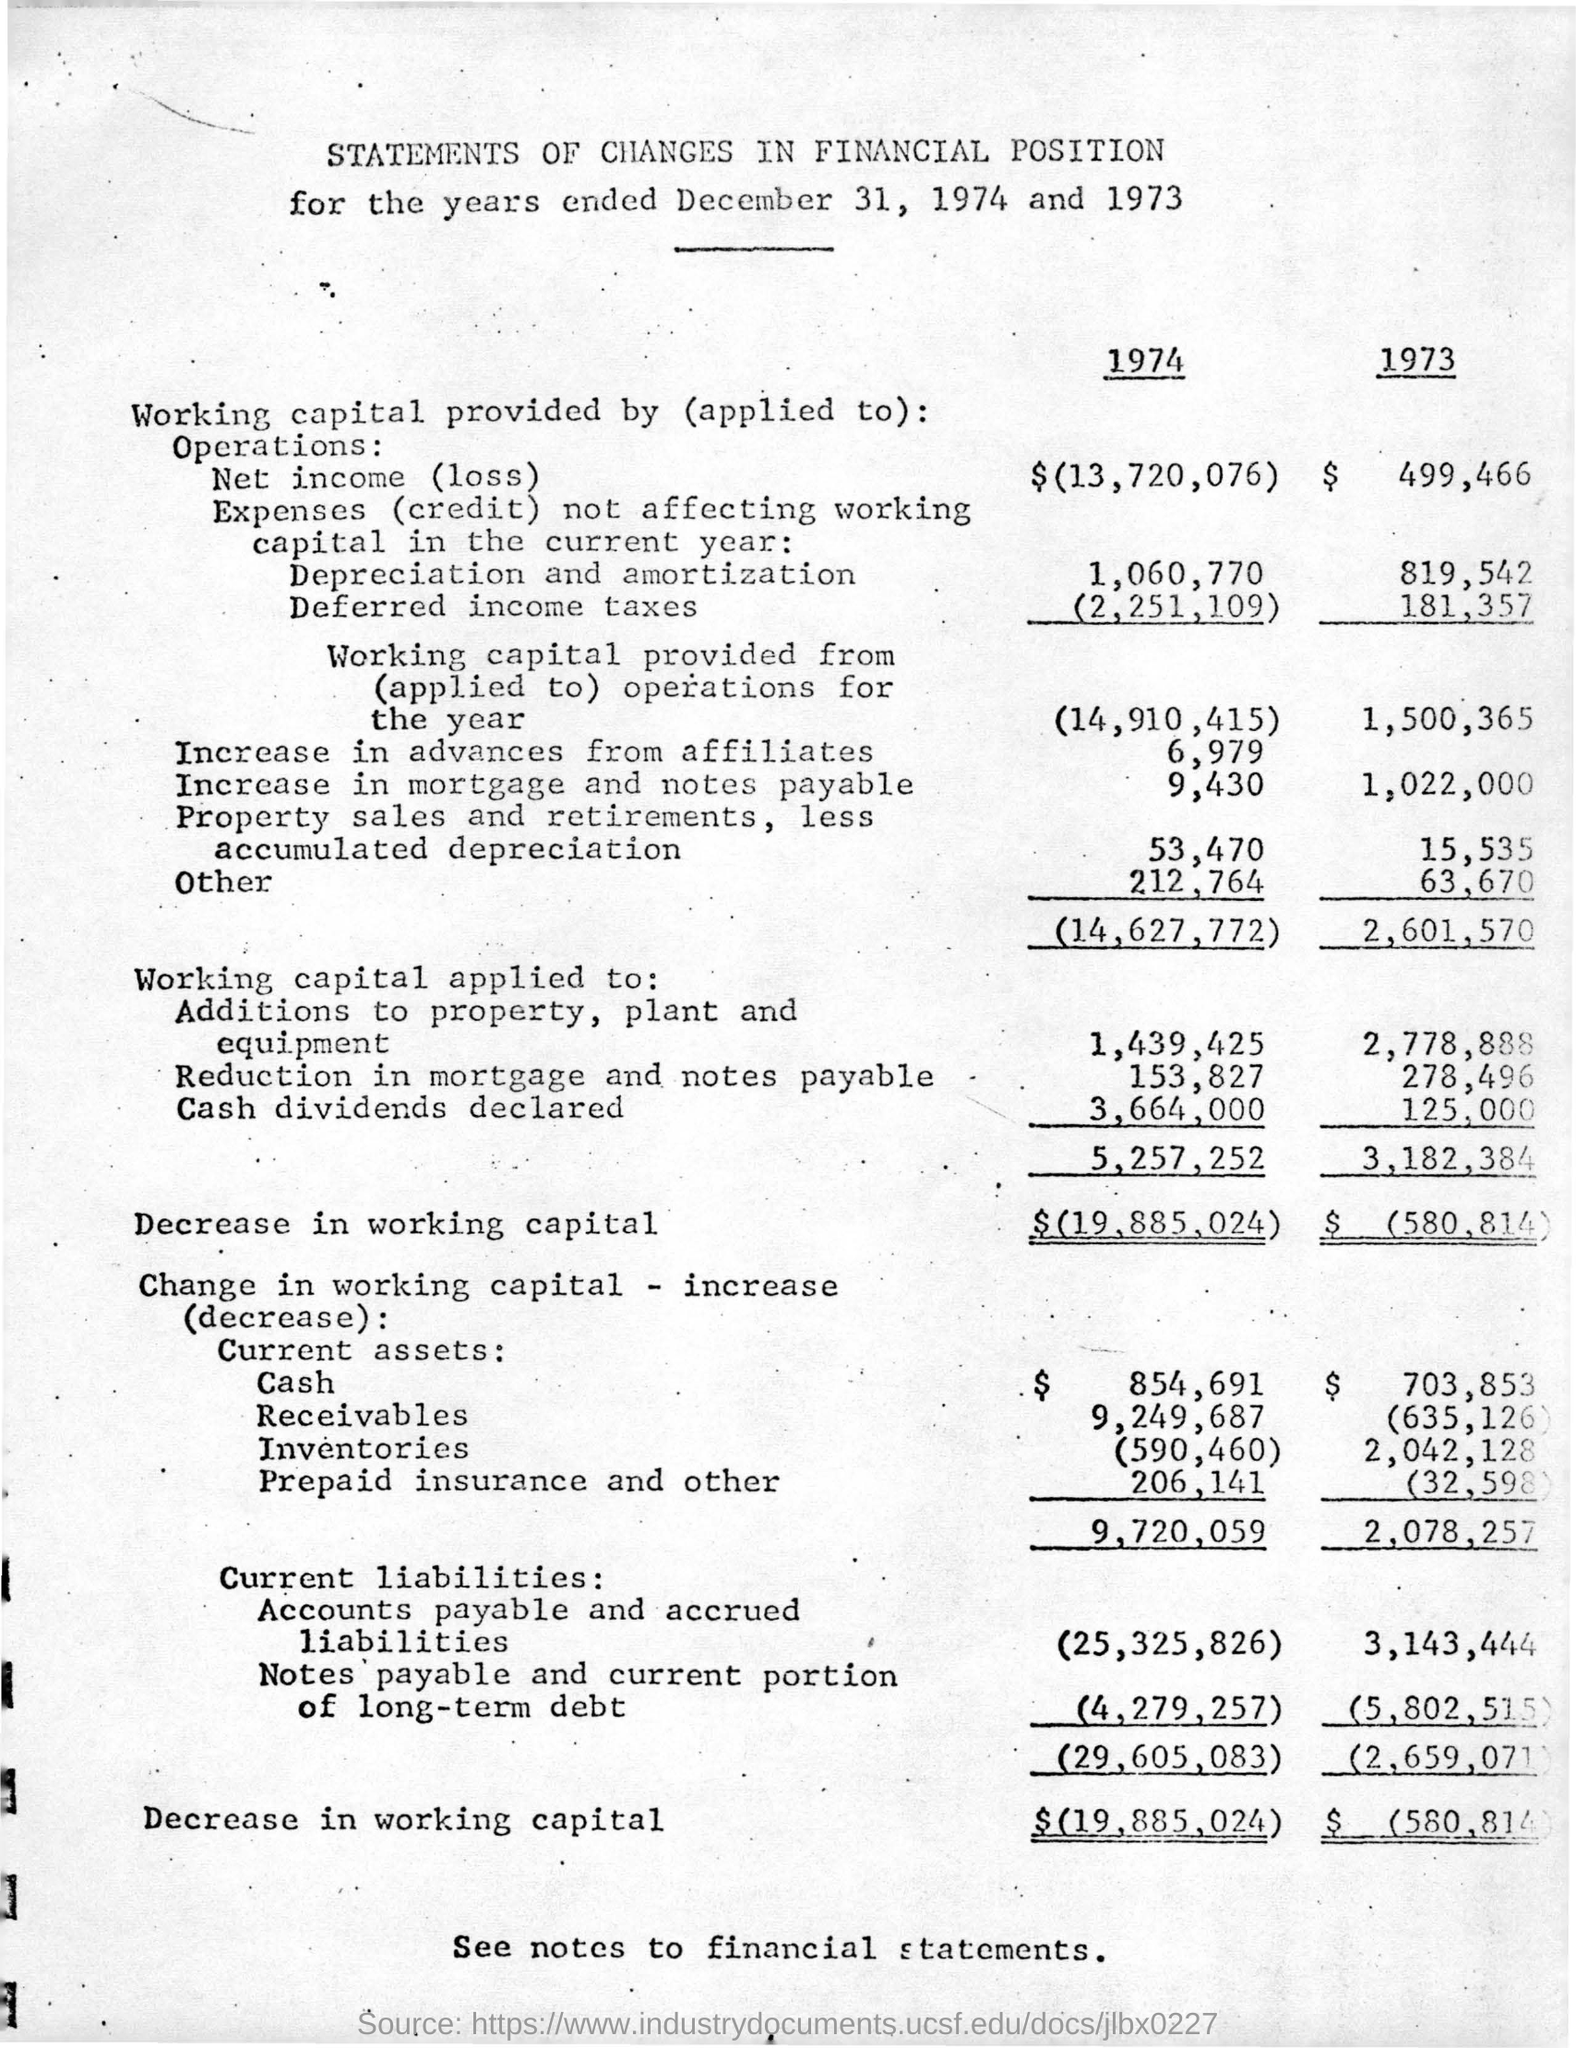What are the two years taken for the statements ?
Make the answer very short. 1974 AND 1973. What is the  Decrease in working capital for the year 1974 ?
Your answer should be very brief. $(19,885,024). What is the date taken for the two years ?
Your answer should be very brief. December 31. How much is the cash dividends declared for the year 1974?
Offer a terse response. 3,664,000. 